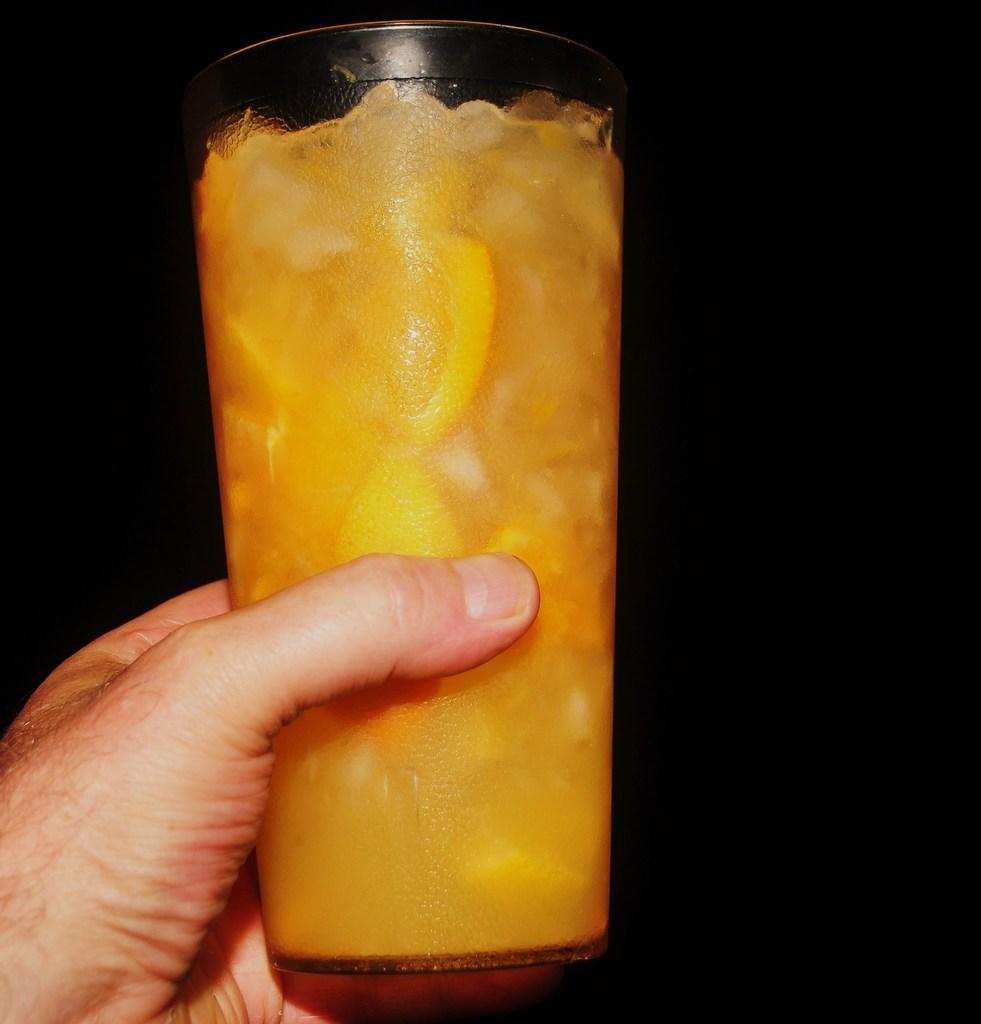What is the person in the image holding? The person is holding a glass. What is inside the glass that the person is holding? There is orange juice in the glass. How many rings can be seen on the person's fingers in the image? There is no information about rings on the person's fingers in the image. What type of party is depicted in the image? There is no party depicted in the image; it only shows a person holding a glass of orange juice. 